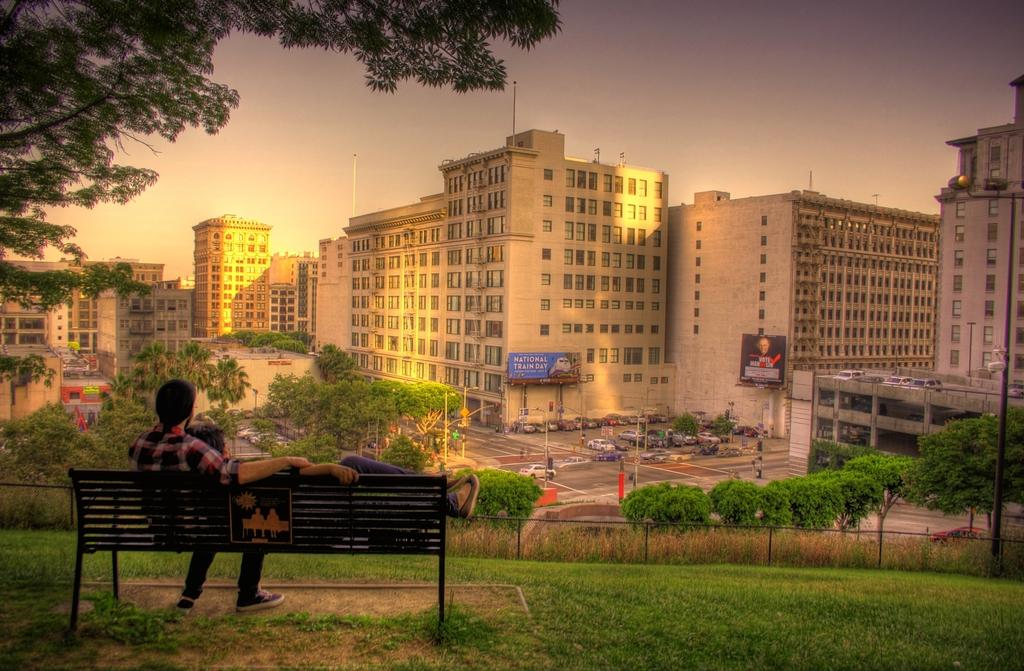How many people are sitting on the bench in the image? There are two persons sitting on a bench in the image. What can be seen in the background of the image? Vehicles, a road, trees, buildings, and the sky are visible in the background of the image. What type of setting is depicted in the image? The image shows an outdoor scene with a bench, likely in a public area or park. What type of pancake is the creator of the bench eating in the image? There is no pancake or creator of the bench present in the image. What type of metal was used to construct the bench in the image? The type of metal used to construct the bench is not visible or mentioned in the image. 